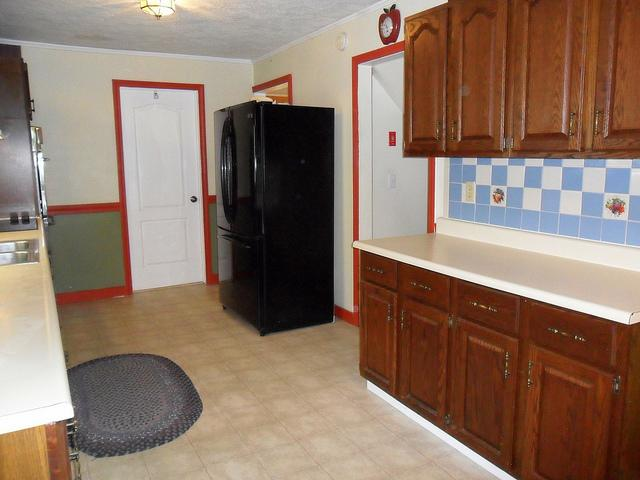What material is the floor made of? Please explain your reasoning. vinyl. Most kitchens you a surface that is easy to clean and won't rot or rust. 